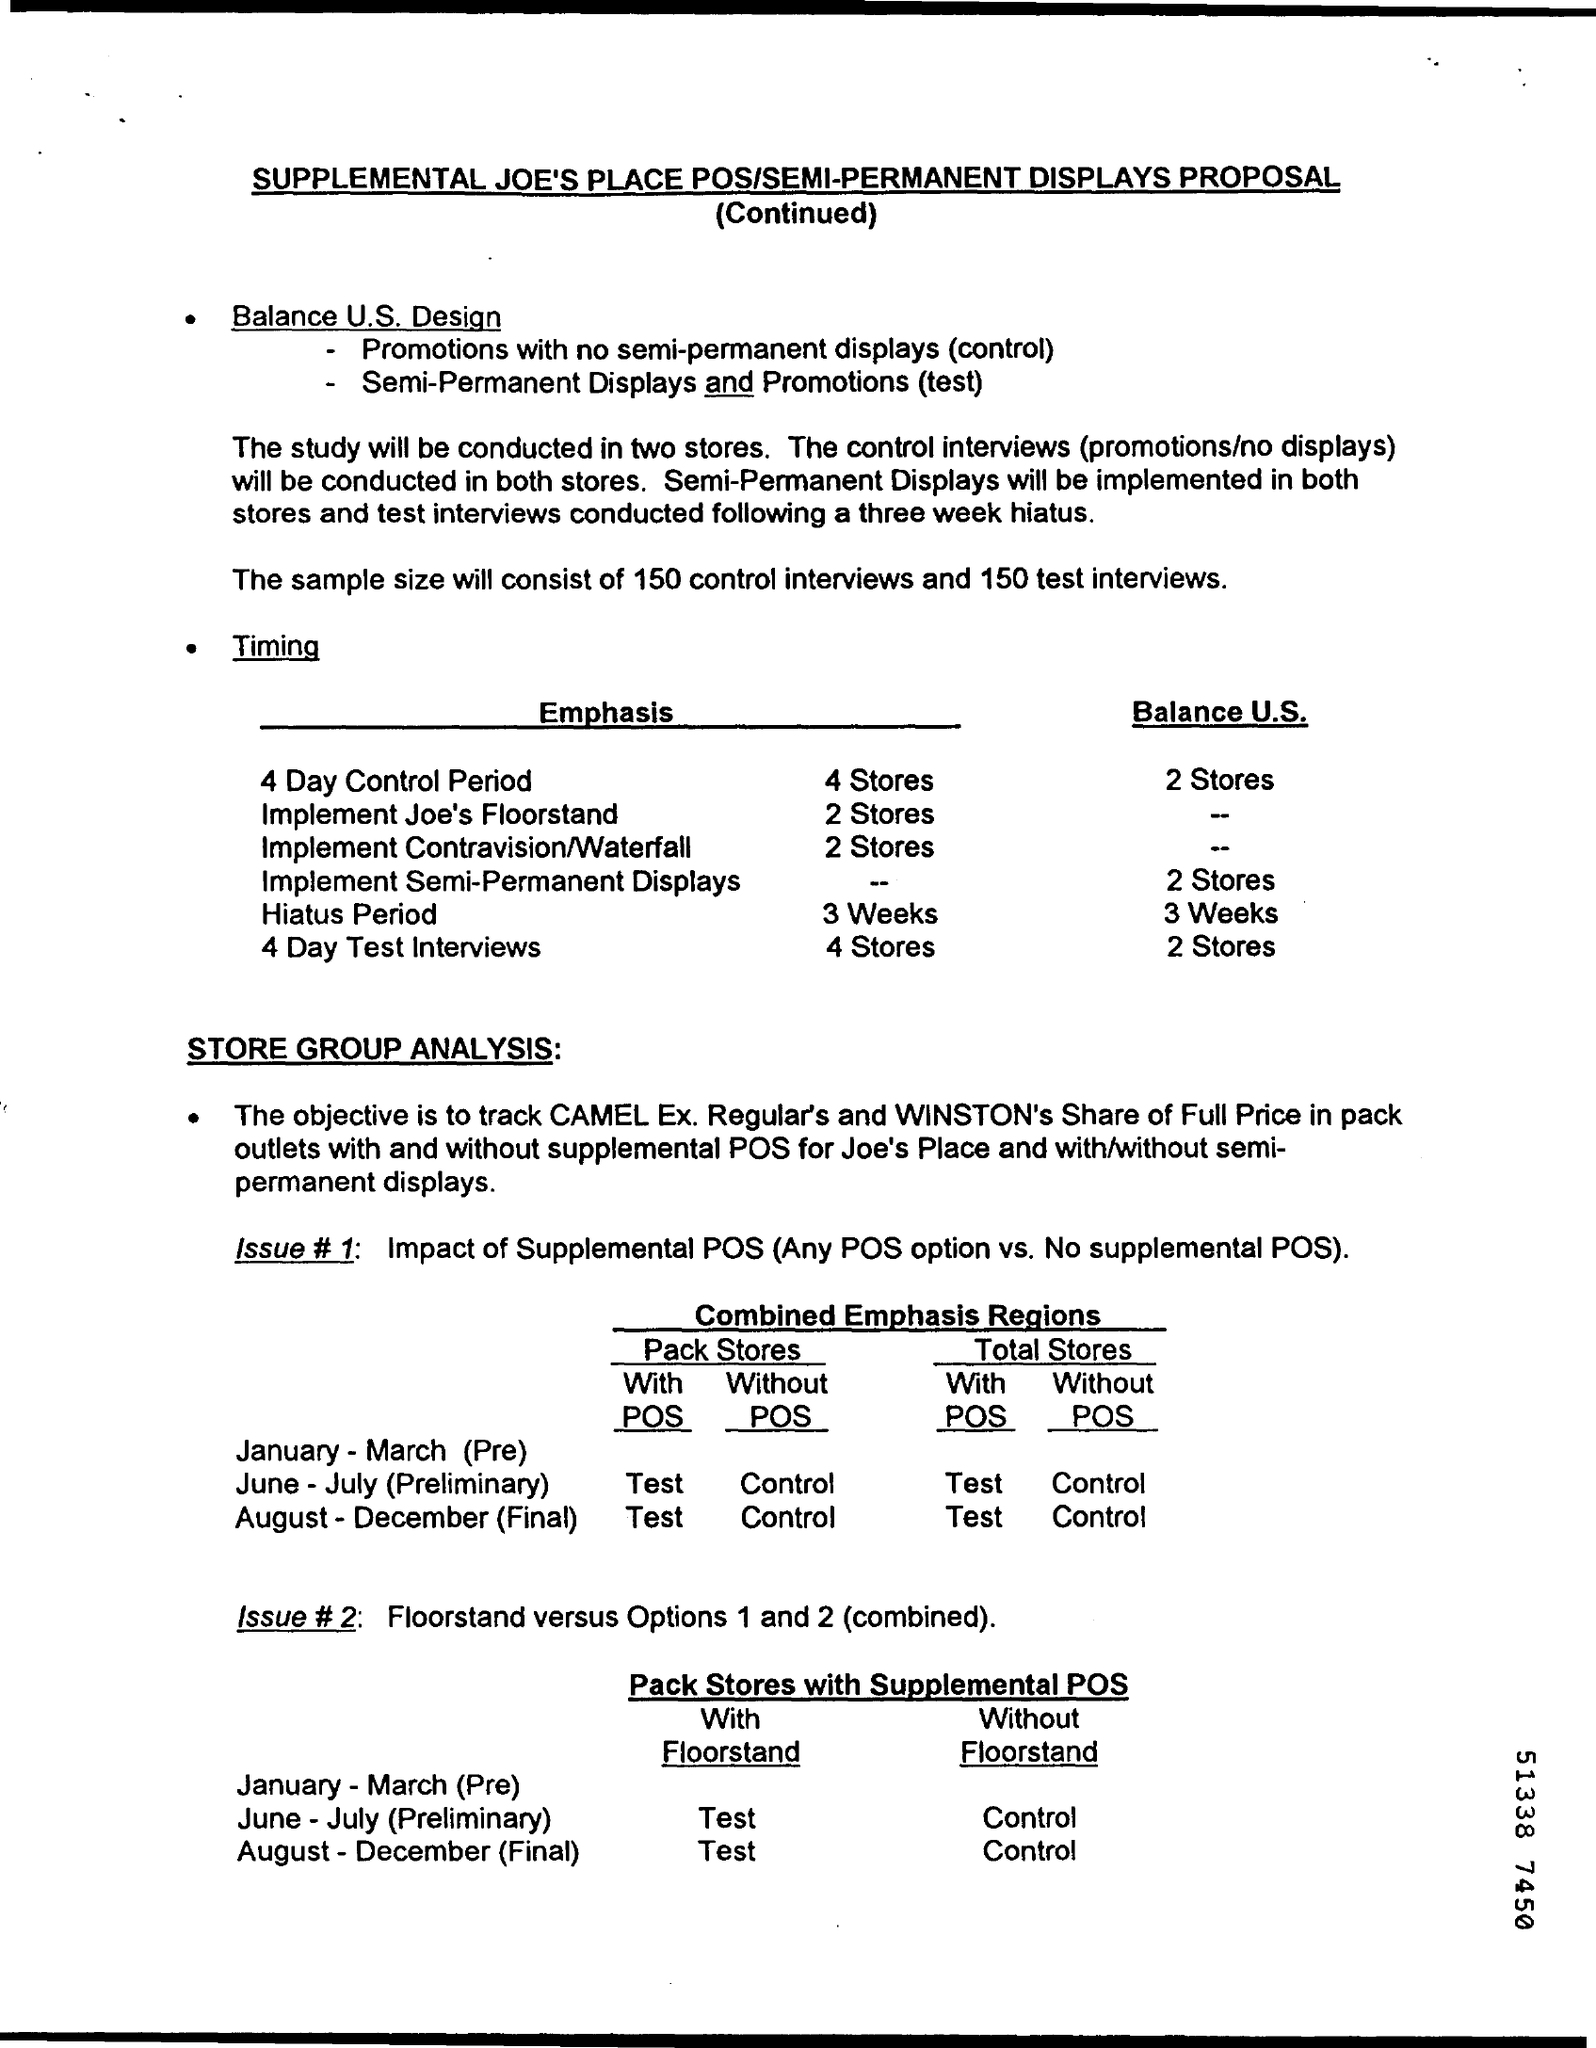Indicate a few pertinent items in this graphic. The sample size for the test interviews will be 150 participants. The sample size for the control interviews will be 150. 